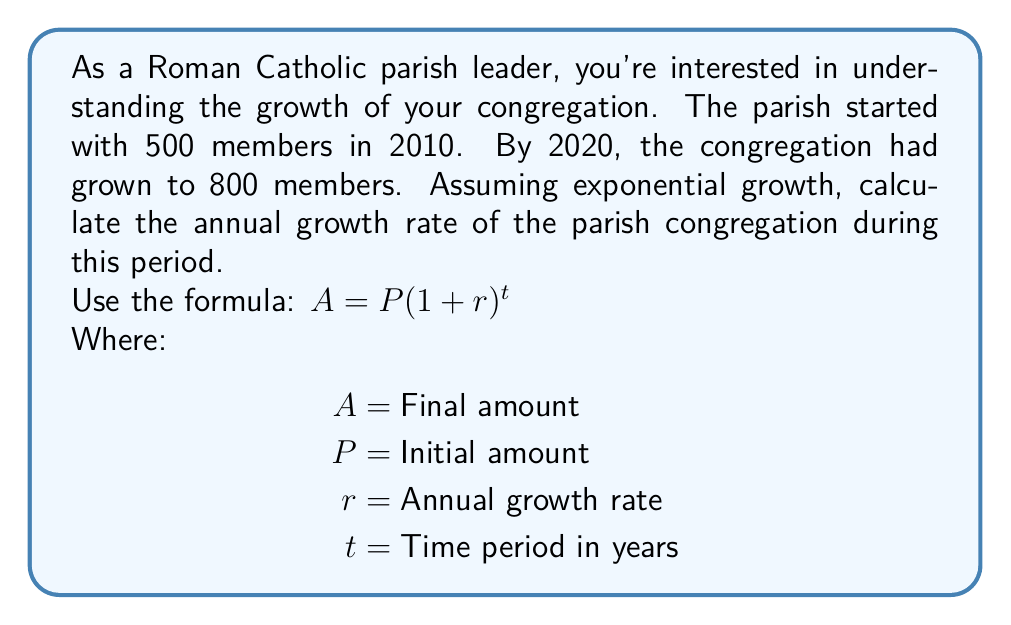Provide a solution to this math problem. To solve this problem, we'll use the exponential growth formula and the given information:

1) We know:
   $P = 500$ (initial members in 2010)
   $A = 800$ (final members in 2020)
   $t = 10$ years (2010 to 2020)

2) Let's plug these values into the formula:
   $800 = 500(1 + r)^{10}$

3) Divide both sides by 500:
   $\frac{800}{500} = (1 + r)^{10}$

4) Simplify:
   $1.6 = (1 + r)^{10}$

5) Take the 10th root of both sides:
   $\sqrt[10]{1.6} = 1 + r$

6) Subtract 1 from both sides:
   $\sqrt[10]{1.6} - 1 = r$

7) Calculate:
   $r \approx 1.0484 - 1 = 0.0484$

8) Convert to percentage:
   $r \approx 0.0484 \times 100\% = 4.84\%$

Therefore, the annual growth rate of the parish congregation is approximately 4.84%.
Answer: 4.84% 